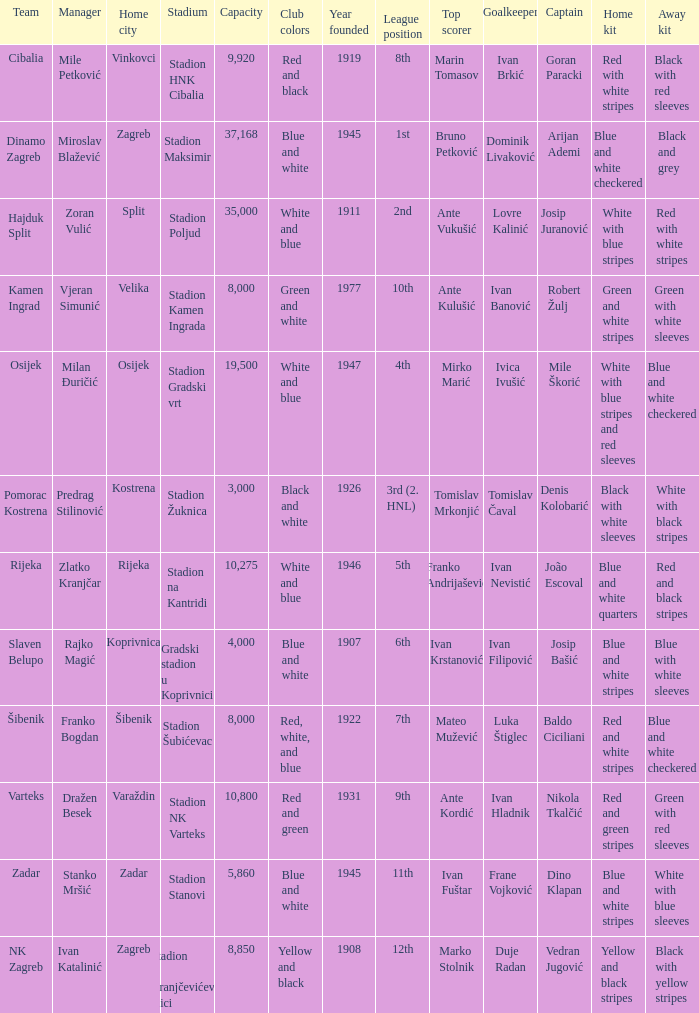What is the stadium of the NK Zagreb? Stadion u Kranjčevićevoj ulici. 